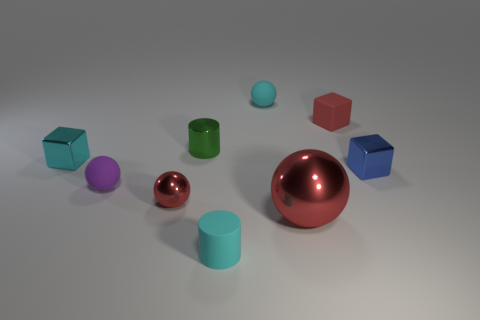How big is the blue metallic cube?
Your answer should be compact. Small. The red metallic object left of the small cylinder that is behind the big red object is what shape?
Make the answer very short. Sphere. There is a small metallic block left of the large sphere; does it have the same color as the tiny matte cylinder?
Provide a short and direct response. Yes. There is a red sphere on the right side of the tiny sphere that is behind the rubber cube; what size is it?
Your response must be concise. Large. What is the material of the purple ball that is the same size as the blue metal object?
Give a very brief answer. Rubber. What number of other things are the same size as the blue cube?
Provide a succinct answer. 7. What number of cubes are either big blue rubber objects or blue metallic objects?
Offer a terse response. 1. The cylinder behind the tiny cube to the left of the tiny red object that is on the left side of the small green metallic thing is made of what material?
Provide a short and direct response. Metal. What material is the sphere that is the same color as the matte cylinder?
Make the answer very short. Rubber. How many small green things are made of the same material as the small purple ball?
Make the answer very short. 0. 